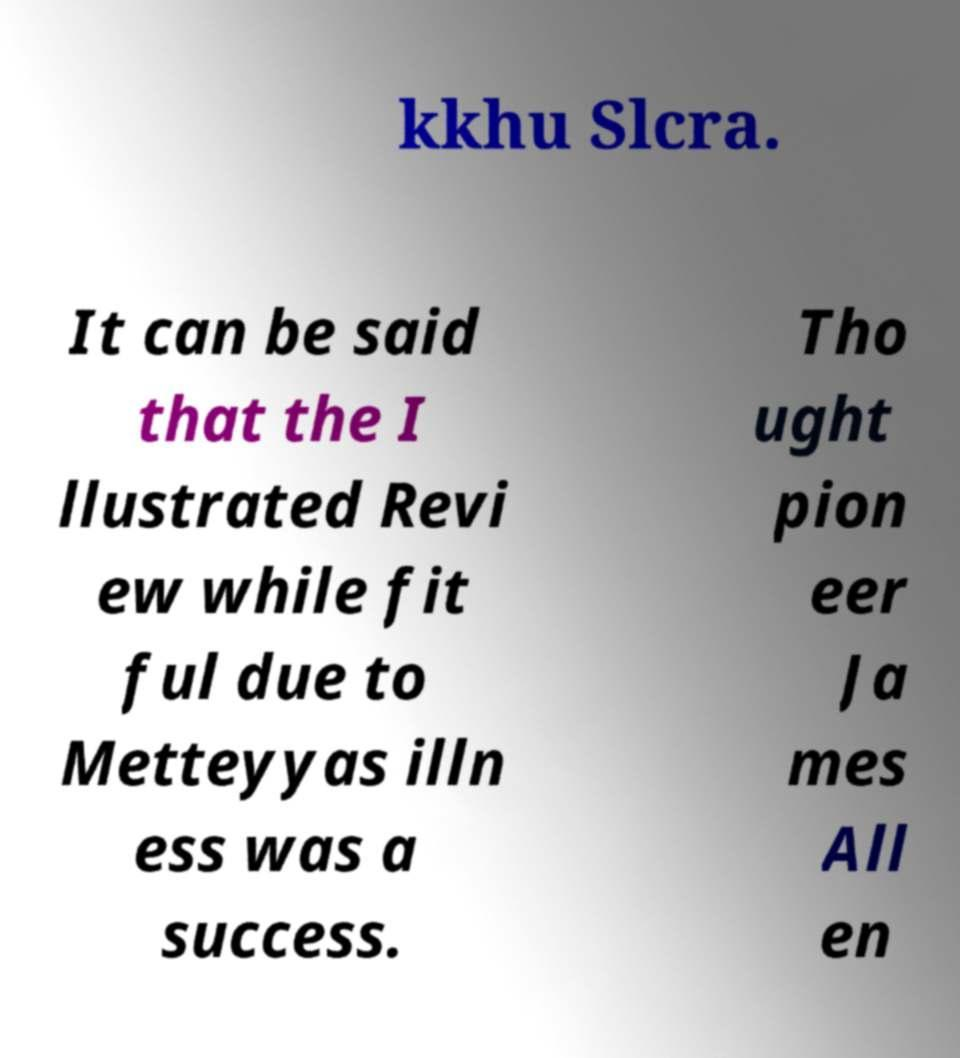Please read and relay the text visible in this image. What does it say? kkhu Slcra. It can be said that the I llustrated Revi ew while fit ful due to Metteyyas illn ess was a success. Tho ught pion eer Ja mes All en 